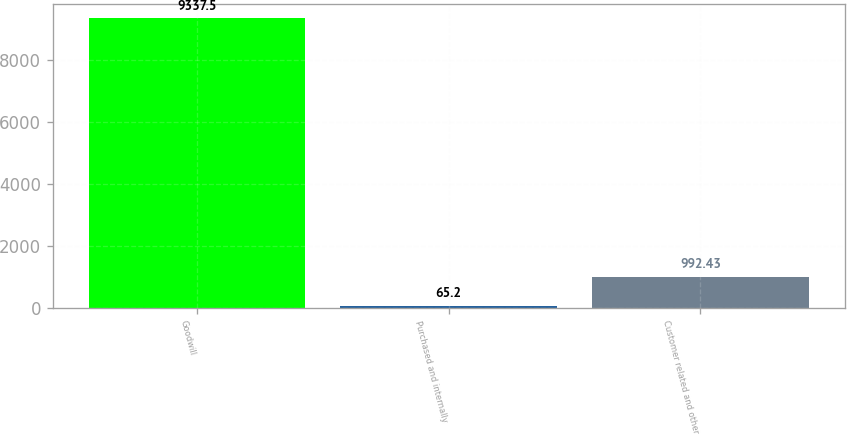Convert chart. <chart><loc_0><loc_0><loc_500><loc_500><bar_chart><fcel>Goodwill<fcel>Purchased and internally<fcel>Customer related and other<nl><fcel>9337.5<fcel>65.2<fcel>992.43<nl></chart> 